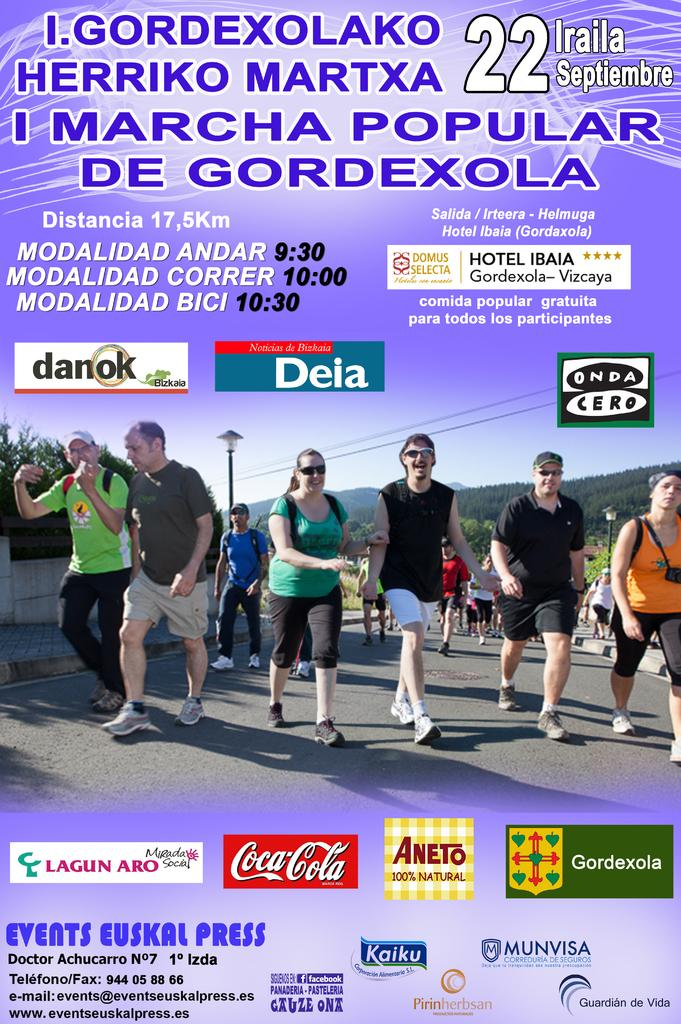What are the people in the image doing? There is a group of people walking on the road in the image. What can be seen in the background of the image? There are trees, hills, a pole, and the sky visible in the background of the image. What is the source of light in the image? The source of light in the image is not specified, but there is light visible. Are there any watermarks on the image? Yes, there are watermarks on the image. How many chairs are visible in the image? There are no chairs present in the image. Is the scene in the image quiet or noisy? The image does not provide any information about the noise level, so it cannot be determined if the scene is quiet or noisy. 